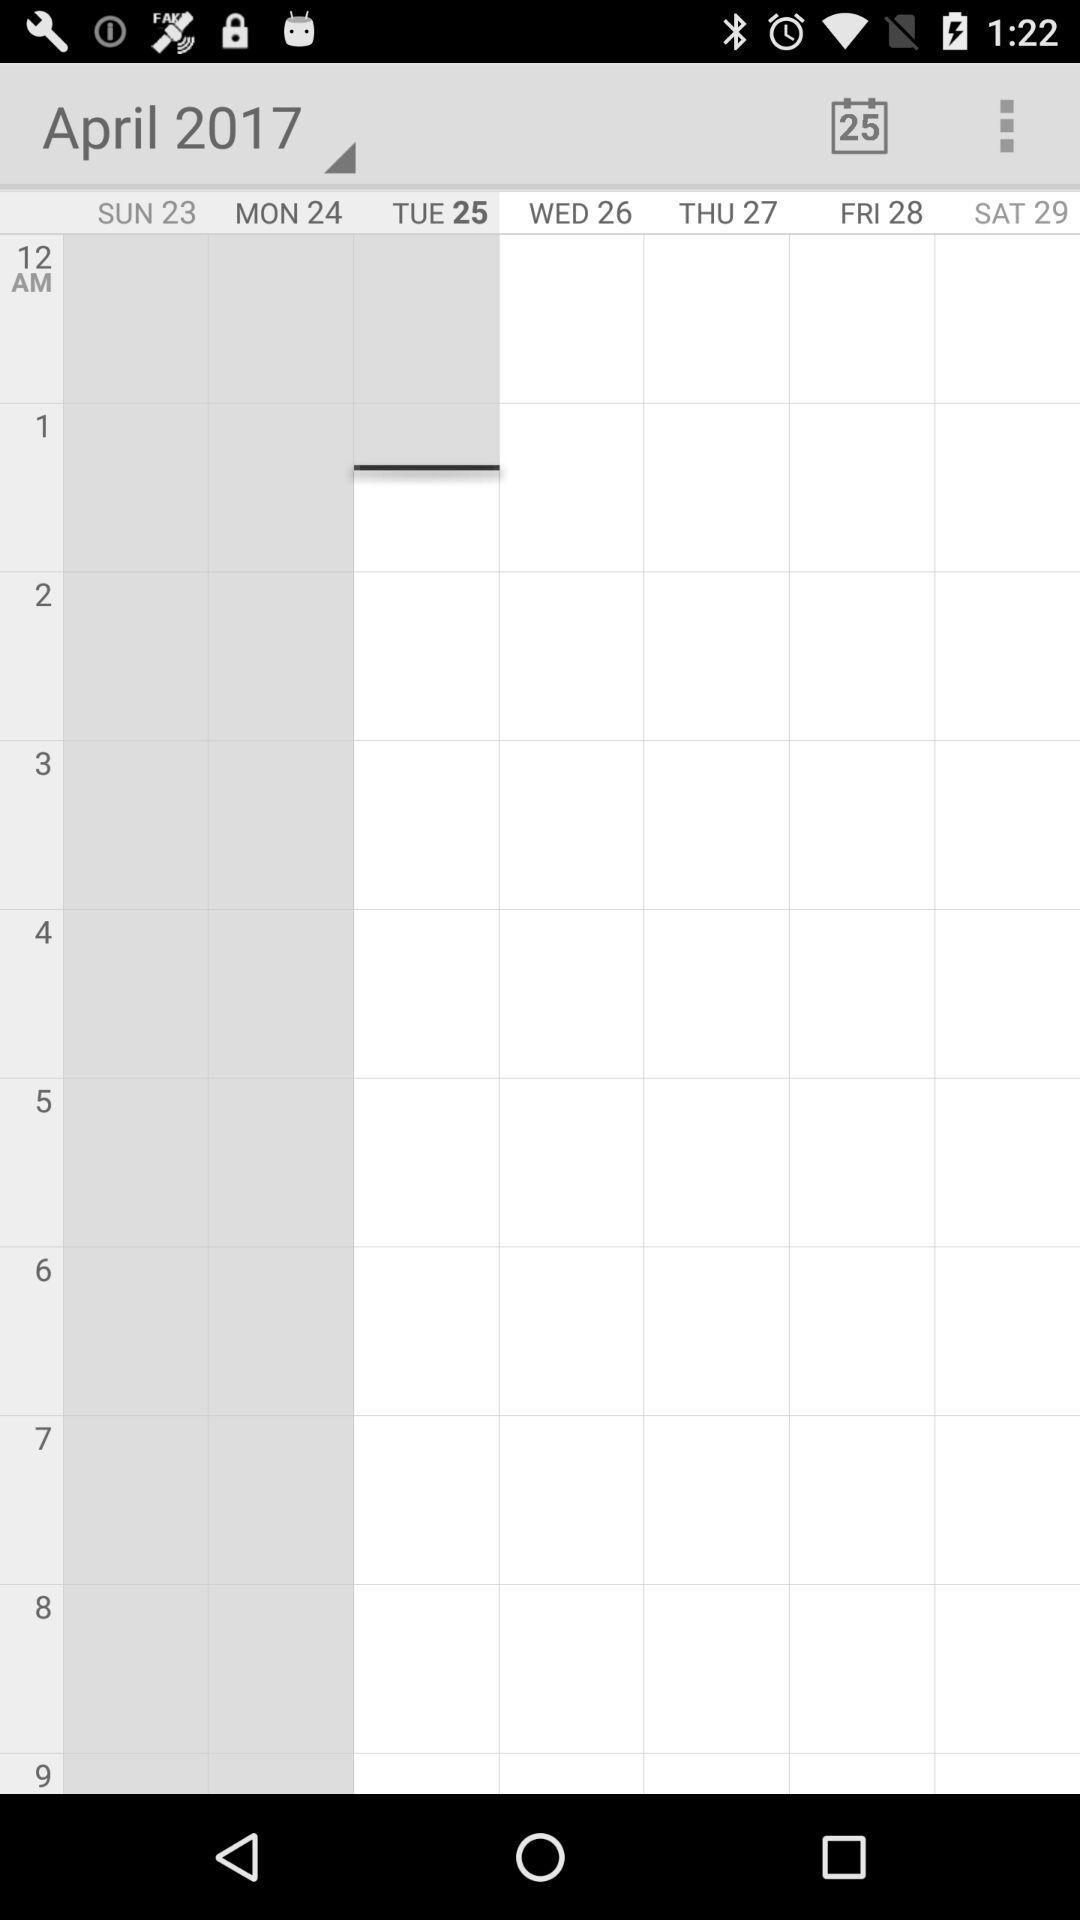Which month and year are selected? The selected month and year are April and 2017. 